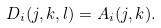Convert formula to latex. <formula><loc_0><loc_0><loc_500><loc_500>D _ { i } ( j , k , l ) = A _ { i } ( j , k ) .</formula> 